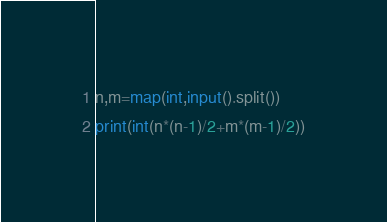Convert code to text. <code><loc_0><loc_0><loc_500><loc_500><_Python_>n,m=map(int,input().split())
print(int(n*(n-1)/2+m*(m-1)/2))</code> 